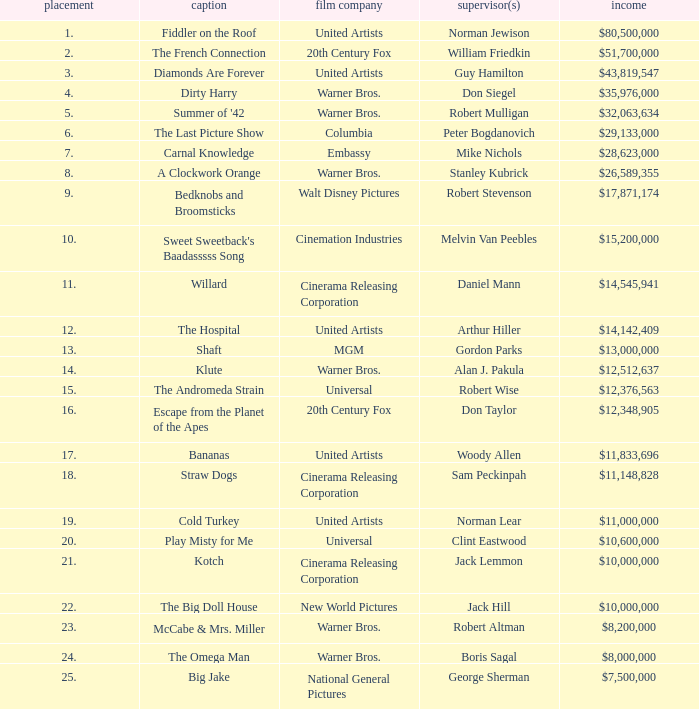What is the standing of the title with a gross income of $26,589,355? 8.0. 